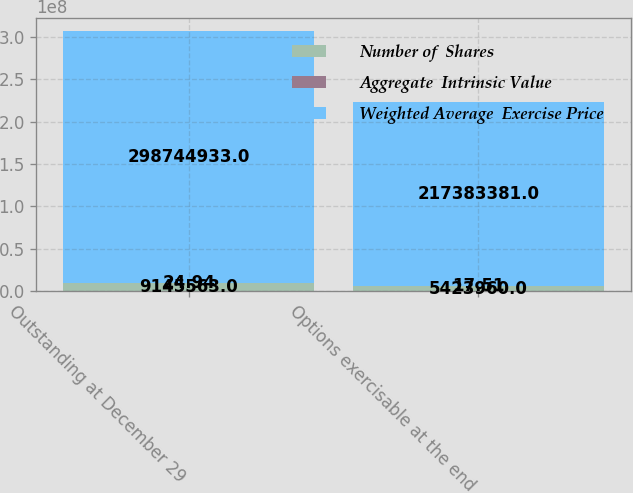Convert chart. <chart><loc_0><loc_0><loc_500><loc_500><stacked_bar_chart><ecel><fcel>Outstanding at December 29<fcel>Options exercisable at the end<nl><fcel>Number of  Shares<fcel>9.14556e+06<fcel>5.42396e+06<nl><fcel>Aggregate  Intrinsic Value<fcel>24.94<fcel>17.51<nl><fcel>Weighted Average  Exercise Price<fcel>2.98745e+08<fcel>2.17383e+08<nl></chart> 